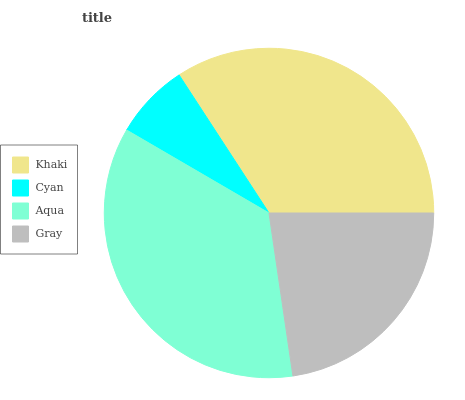Is Cyan the minimum?
Answer yes or no. Yes. Is Aqua the maximum?
Answer yes or no. Yes. Is Aqua the minimum?
Answer yes or no. No. Is Cyan the maximum?
Answer yes or no. No. Is Aqua greater than Cyan?
Answer yes or no. Yes. Is Cyan less than Aqua?
Answer yes or no. Yes. Is Cyan greater than Aqua?
Answer yes or no. No. Is Aqua less than Cyan?
Answer yes or no. No. Is Khaki the high median?
Answer yes or no. Yes. Is Gray the low median?
Answer yes or no. Yes. Is Gray the high median?
Answer yes or no. No. Is Aqua the low median?
Answer yes or no. No. 